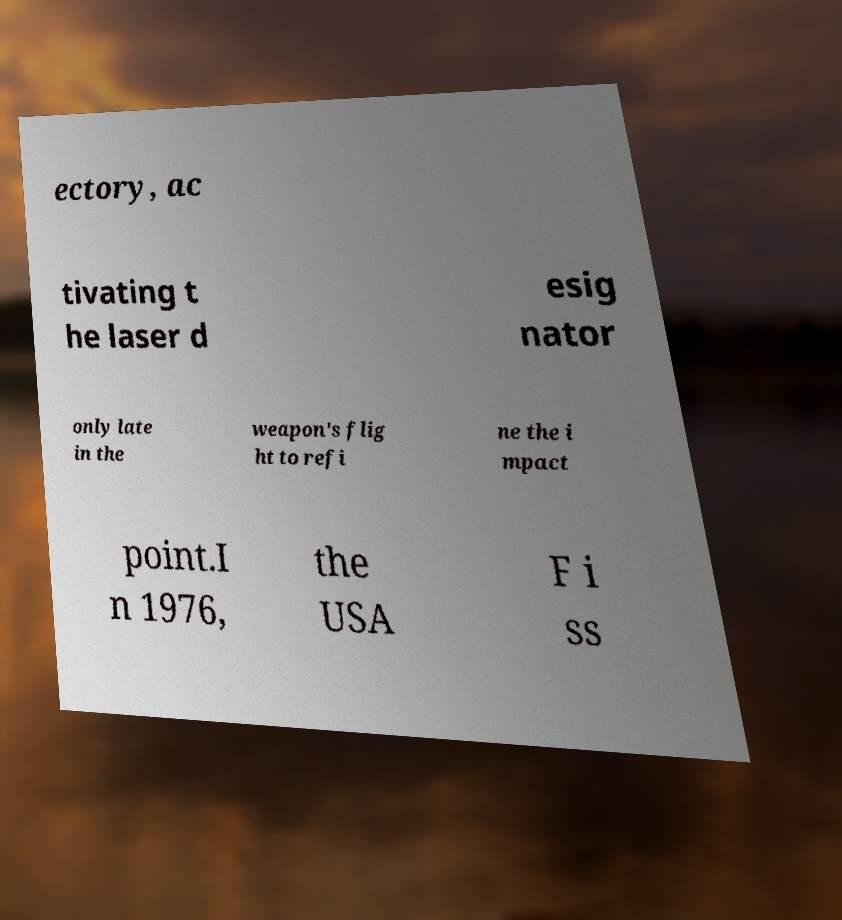Please read and relay the text visible in this image. What does it say? ectory, ac tivating t he laser d esig nator only late in the weapon's flig ht to refi ne the i mpact point.I n 1976, the USA F i ss 